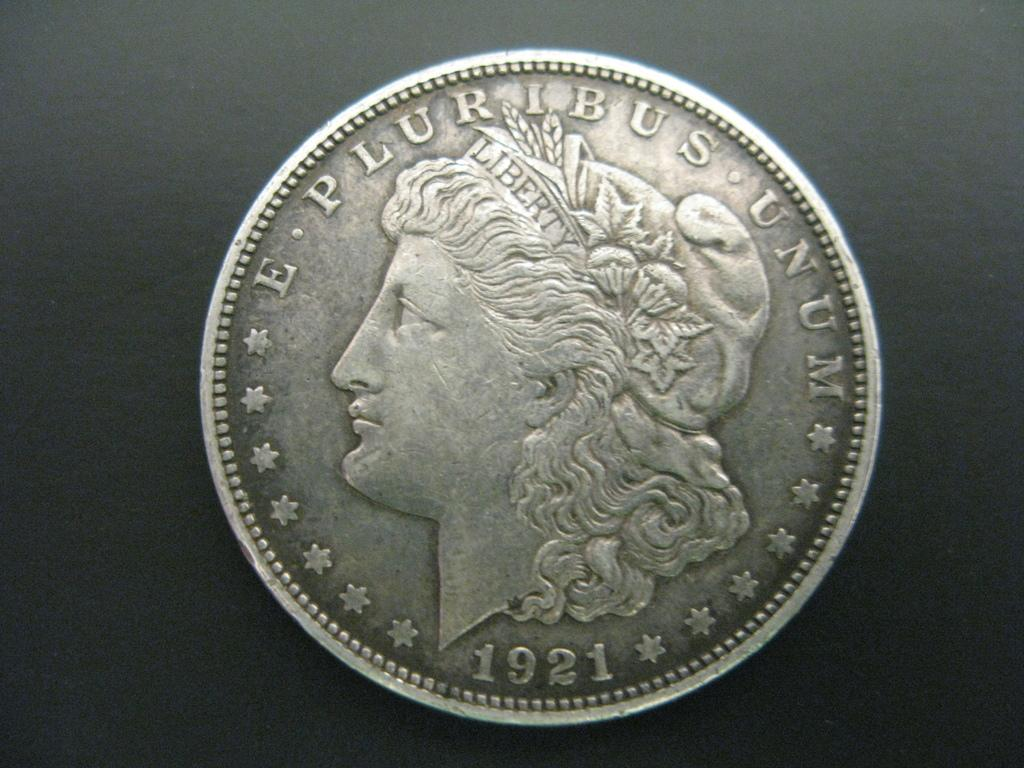<image>
Summarize the visual content of the image. A silver coin says E Pluribus Unum 1921 and has a woman's head featured on it. 